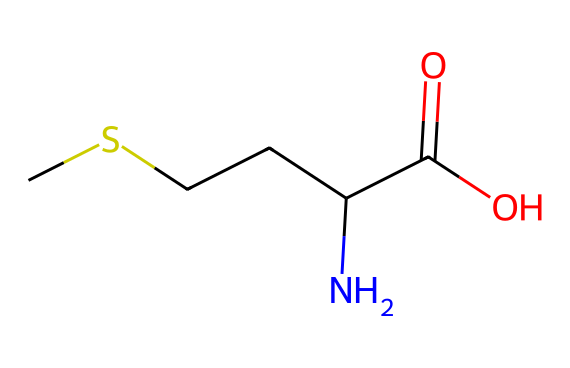What is the name of this chemical? The SMILES representation corresponds to an amino acid structure, specifically methionine, which is indicated by the presence of a sulfur atom and the amino carboxylic acid functional groups.
Answer: methionine How many carbon atoms are present in methionine? Analyzing the SMILES, we count four carbon atoms (C) in the straight-chain structure before reaching the nitrogen and carboxylic acid groups.
Answer: four How many hydrogen atoms are in methionine? The accounting of hydrogen (H) atoms is based on the saturation of the carbon and nitrogen atoms; considering common valency rules in organic chemistry, methionine has nine hydrogen atoms.
Answer: nine What functional groups are present in methionine? The chemical structure shows an amino group (-NH2) and a carboxylic acid group (-COOH), which are recognized as key functional groups in amino acids.
Answer: amino and carboxylic acid What type of compound is methionine classified as? Methionine contains both an amino group and a carboxylic acid, placing it in the classification of amino acids, and additionally, it contains sulfur indicating its organosulfur character.
Answer: amino acid Why is methionine considered essential? Methionine is termed essential because the human body cannot synthesize it, making it necessary to obtain through diet; this links directly to its role in protein formation.
Answer: essential How does the presence of sulfur in methionine affect its properties? The sulfur contributes to the unique properties of methionine, such as its role in protein structure and function, making it a vital component in many biochemical processes compared to amino acids without sulfur.
Answer: affects properties 